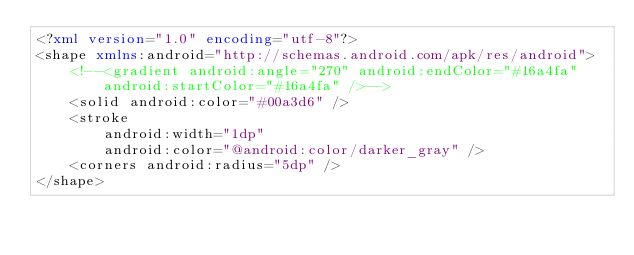Convert code to text. <code><loc_0><loc_0><loc_500><loc_500><_XML_><?xml version="1.0" encoding="utf-8"?>
<shape xmlns:android="http://schemas.android.com/apk/res/android">
    <!--<gradient android:angle="270" android:endColor="#16a4fa" android:startColor="#16a4fa" />-->
    <solid android:color="#00a3d6" />
    <stroke
        android:width="1dp"
        android:color="@android:color/darker_gray" />
    <corners android:radius="5dp" />
</shape>
</code> 